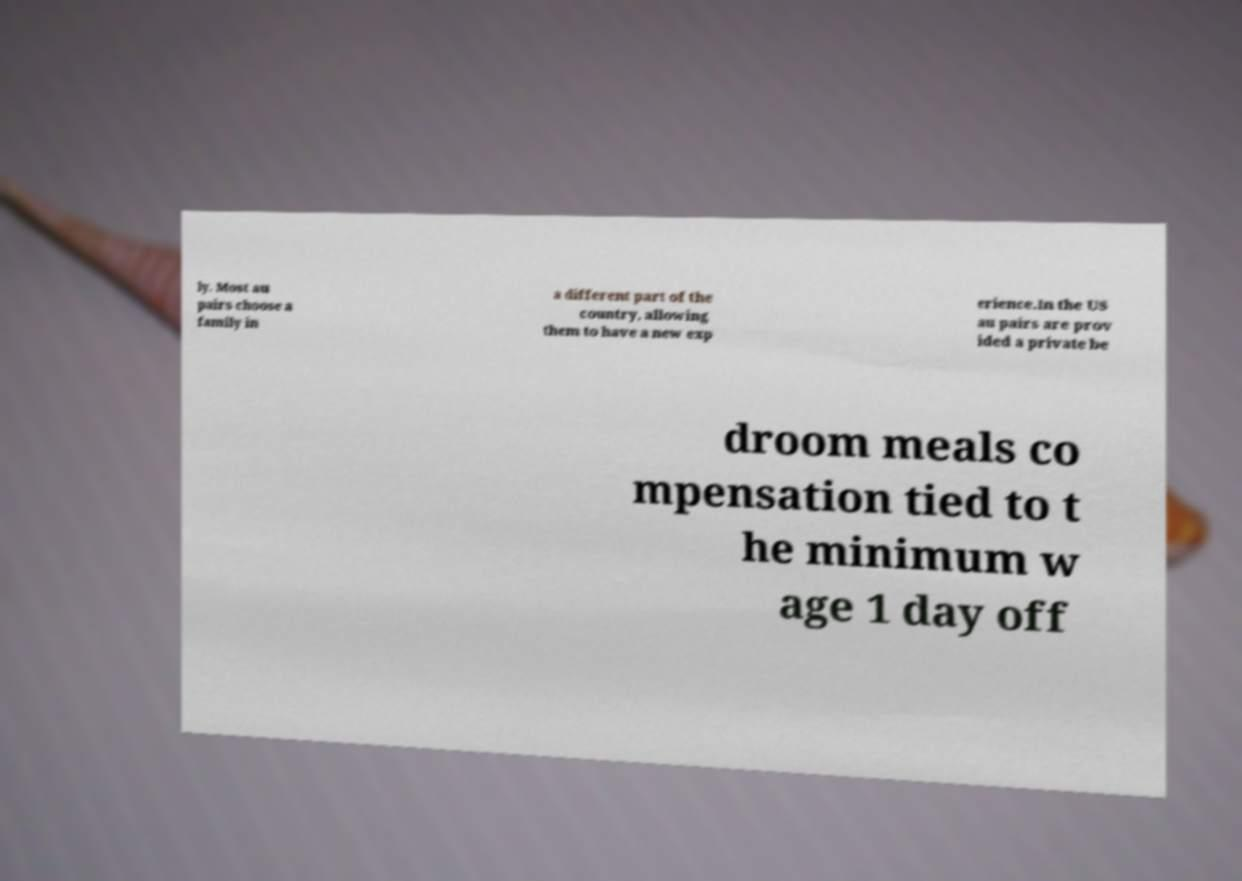There's text embedded in this image that I need extracted. Can you transcribe it verbatim? ly. Most au pairs choose a family in a different part of the country, allowing them to have a new exp erience.In the US au pairs are prov ided a private be droom meals co mpensation tied to t he minimum w age 1 day off 